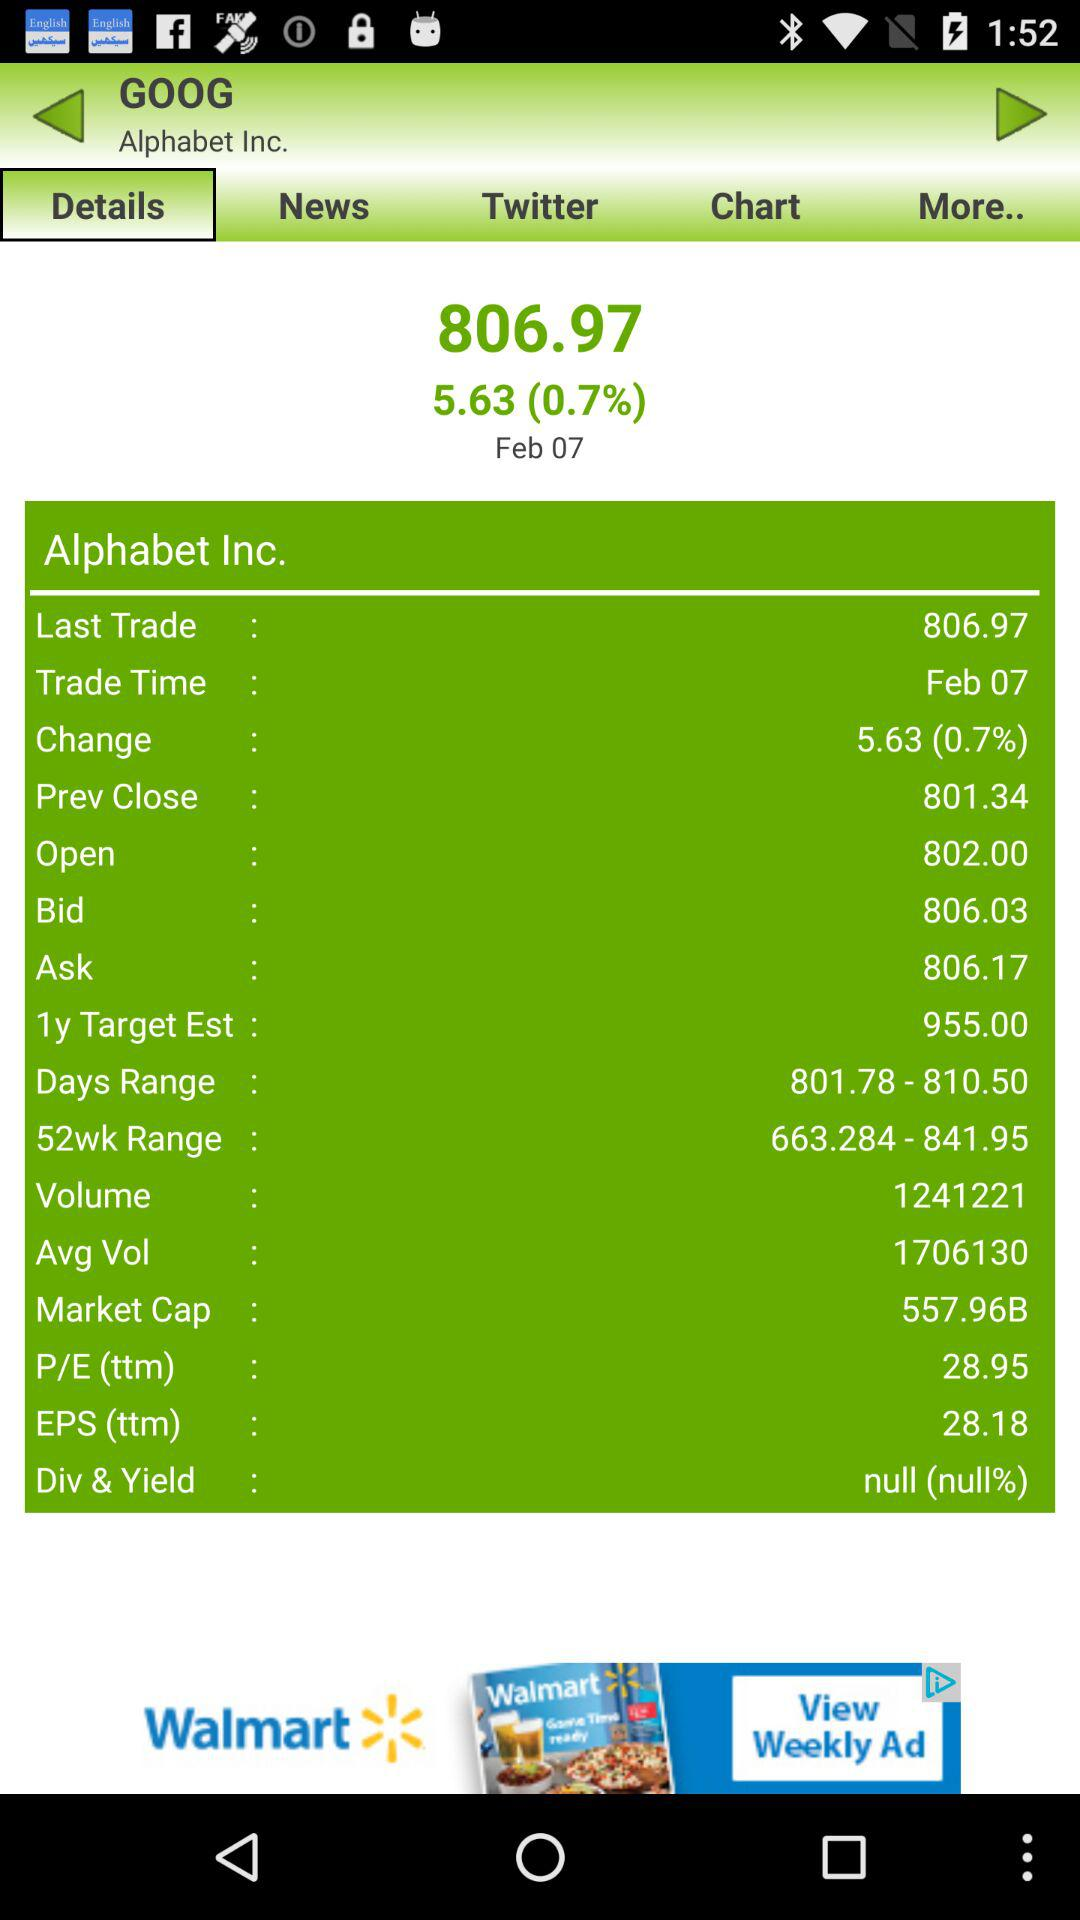What is the day range of "Alphabet Inc."? The day range of "Alphabet Inc." is from 801.78 to 810.50. 